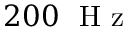<formula> <loc_0><loc_0><loc_500><loc_500>2 0 0 \ H z</formula> 